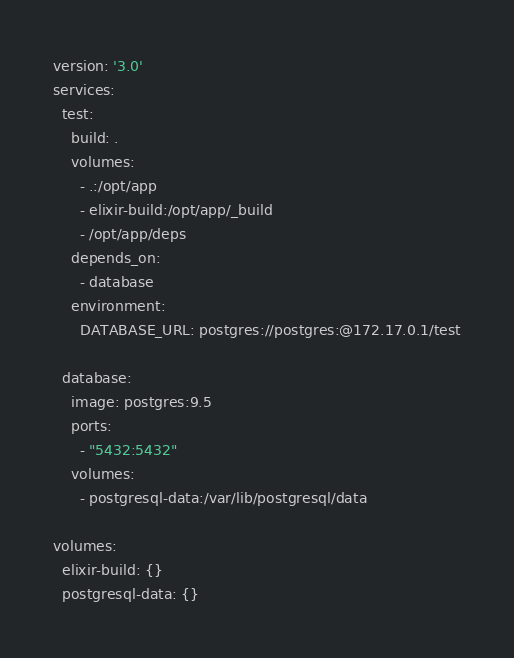Convert code to text. <code><loc_0><loc_0><loc_500><loc_500><_YAML_>version: '3.0'
services:
  test:
    build: .
    volumes:
      - .:/opt/app
      - elixir-build:/opt/app/_build
      - /opt/app/deps
    depends_on:
      - database
    environment:
      DATABASE_URL: postgres://postgres:@172.17.0.1/test

  database:
    image: postgres:9.5
    ports:
      - "5432:5432"
    volumes:
      - postgresql-data:/var/lib/postgresql/data

volumes:
  elixir-build: {}
  postgresql-data: {}
</code> 